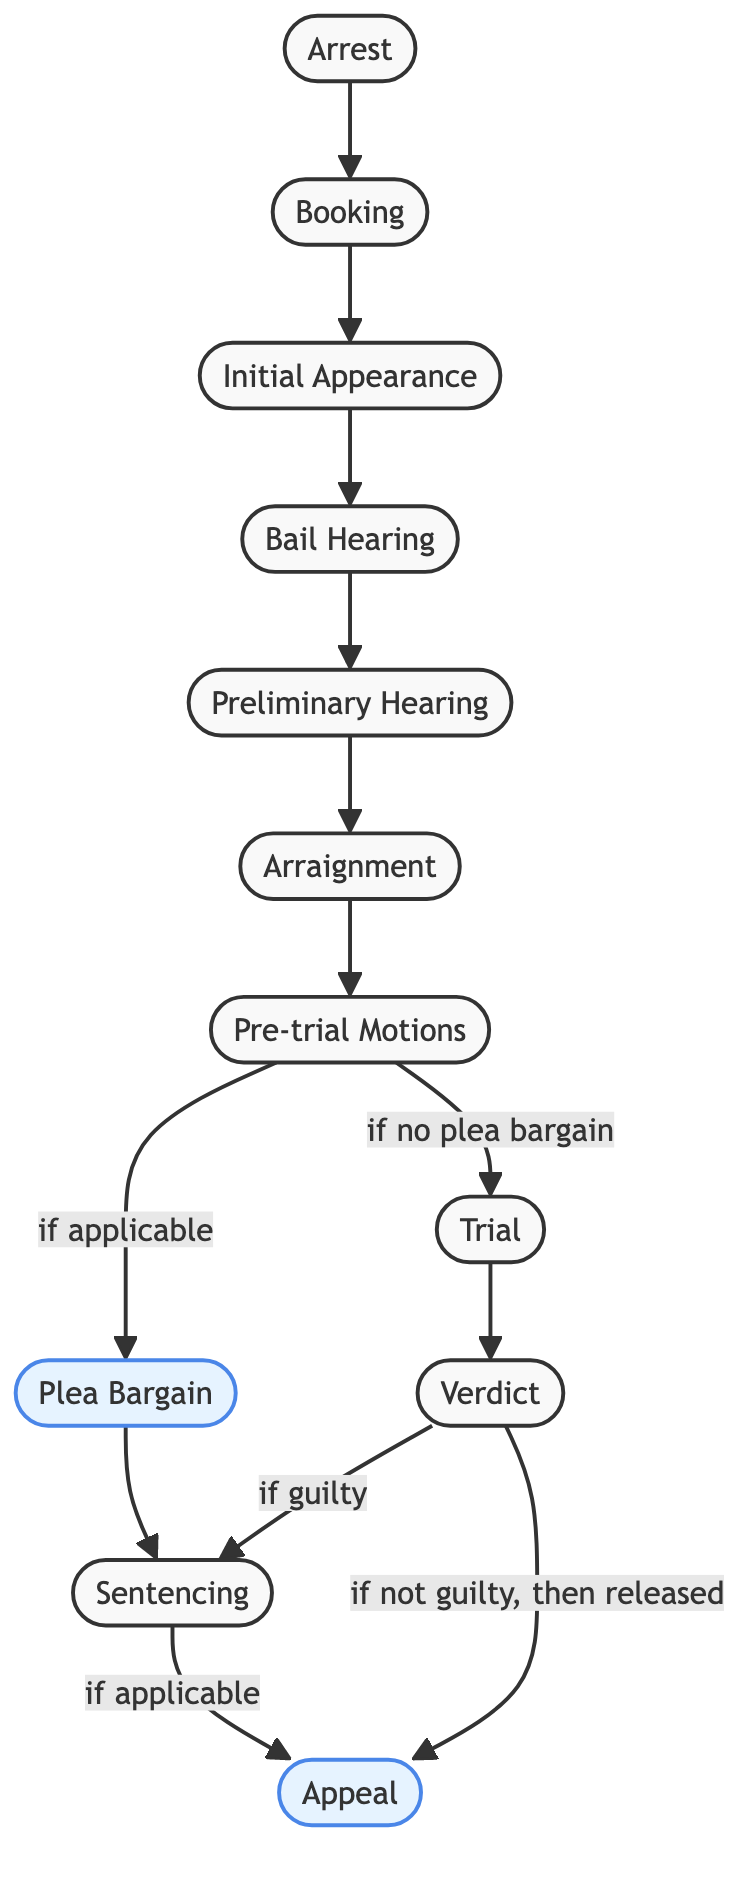What is the first step in the legal process? The diagram starts with "Arrest" as the first node, indicating it is the initial step in the legal process flowchart.
Answer: Arrest How many nodes are there in total? Counting the nodes in the diagram, we have 11 distinct stages, including arrests and potential appeals.
Answer: 11 Which step follows "Initial Appearance"? The flowchart shows that the next step after "Initial Appearance" is "Bail Hearing," according to the directional connection between these two nodes.
Answer: Bail Hearing What happens after a guilty verdict? After a "Verdict" indicates a guilty outcome, the flowchart directs to "Sentencing," indicating that this is the subsequent step in the process.
Answer: Sentencing Is "Plea Bargain" mandatory in the process? The diagram indicates that "Plea Bargain" is an optional step since it is connected with an "if applicable" decision branching from "Pre-trial Motions."
Answer: No How does the flow proceed if there is no plea bargain? If there is no plea bargain, the diagram shows that the flow continues from "Pre-trial Motions" directly to the "Trial" stage, illustrating a clear path without the plea bargain.
Answer: Trial What connection leads to "Appeal"? The "Appeal" node is reached through two transitions: from the "Verdict" if the outcome is "not guilty" and after "Sentencing" if applicable, showing two distinct pathways leading to appeal.
Answer: Verdict and Sentencing If a defendant pleads guilty, which step follows next in the diagram? In the case of a guilty plea after the "Plea Bargain," the flowchart leads directly to "Sentencing," establishing the consequent step of the process.
Answer: Sentencing What role does "Preliminary Hearing" play in the flow? The "Preliminary Hearing" serves as a sequential step that follows "Bail Hearing," allowing for clarity in the legal process as depicted in the diagram.
Answer: Sequential step What happens during the "Arraignment" phase? While the diagram does not explicitly detail the actions during "Arraignment," it is placed as a distinct stage after "Preliminary Hearing," indicating its function as part of the legal proceedings.
Answer: Distinct stage 